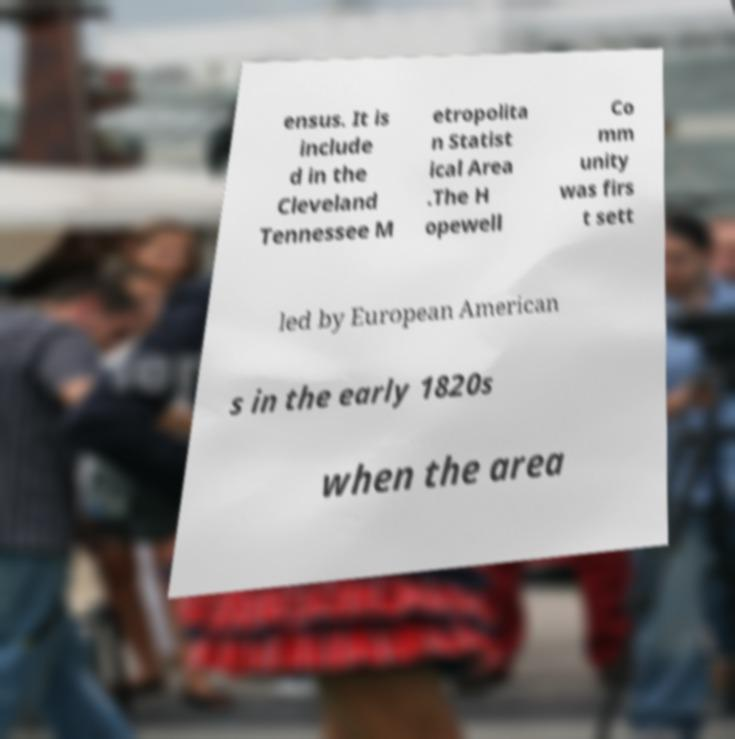Can you accurately transcribe the text from the provided image for me? ensus. It is include d in the Cleveland Tennessee M etropolita n Statist ical Area .The H opewell Co mm unity was firs t sett led by European American s in the early 1820s when the area 